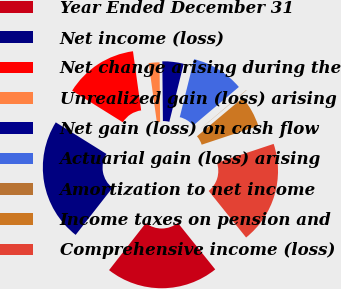Convert chart to OTSL. <chart><loc_0><loc_0><loc_500><loc_500><pie_chart><fcel>Year Ended December 31<fcel>Net income (loss)<fcel>Net change arising during the<fcel>Unrealized gain (loss) arising<fcel>Net gain (loss) on cash flow<fcel>Actuarial gain (loss) arising<fcel>Amortization to net income<fcel>Income taxes on pension and<fcel>Comprehensive income (loss)<nl><fcel>21.33%<fcel>23.31%<fcel>13.94%<fcel>2.03%<fcel>4.02%<fcel>9.97%<fcel>0.05%<fcel>6.0%<fcel>19.34%<nl></chart> 